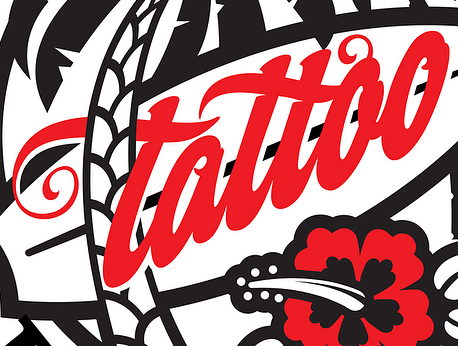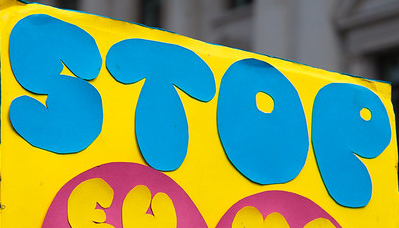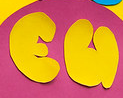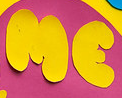Identify the words shown in these images in order, separated by a semicolon. tattao; STOP; EU; ME 